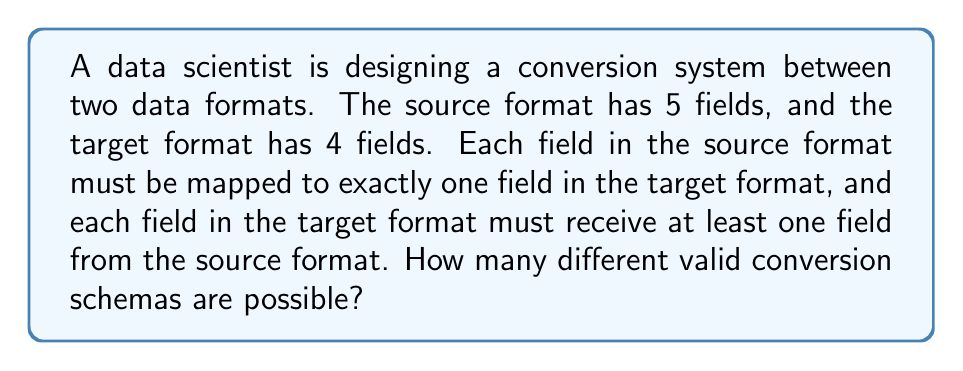Teach me how to tackle this problem. Let's approach this step-by-step:

1) This problem can be modeled as a surjective function from a set of 5 elements to a set of 4 elements.

2) To count the number of surjective functions, we can use the principle of inclusion-exclusion.

3) Let's define:
   $A_i$ = set of functions where the i-th element of the target set is not used

4) The number of surjective functions is:

   $$|\text{Surjective}| = |\text{All}| - |A_1 \cup A_2 \cup A_3 \cup A_4|$$

5) Using the principle of inclusion-exclusion:

   $$|\text{Surjective}| = 4^5 - \binom{4}{1}3^5 + \binom{4}{2}2^5 - \binom{4}{3}1^5$$

6) Let's calculate each term:
   - $4^5 = 1024$
   - $\binom{4}{1}3^5 = 4 \cdot 243 = 972$
   - $\binom{4}{2}2^5 = 6 \cdot 32 = 192$
   - $\binom{4}{3}1^5 = 4 \cdot 1 = 4$

7) Substituting these values:

   $$|\text{Surjective}| = 1024 - 972 + 192 - 4 = 240$$

Therefore, there are 240 different valid conversion schemas possible.
Answer: 240 